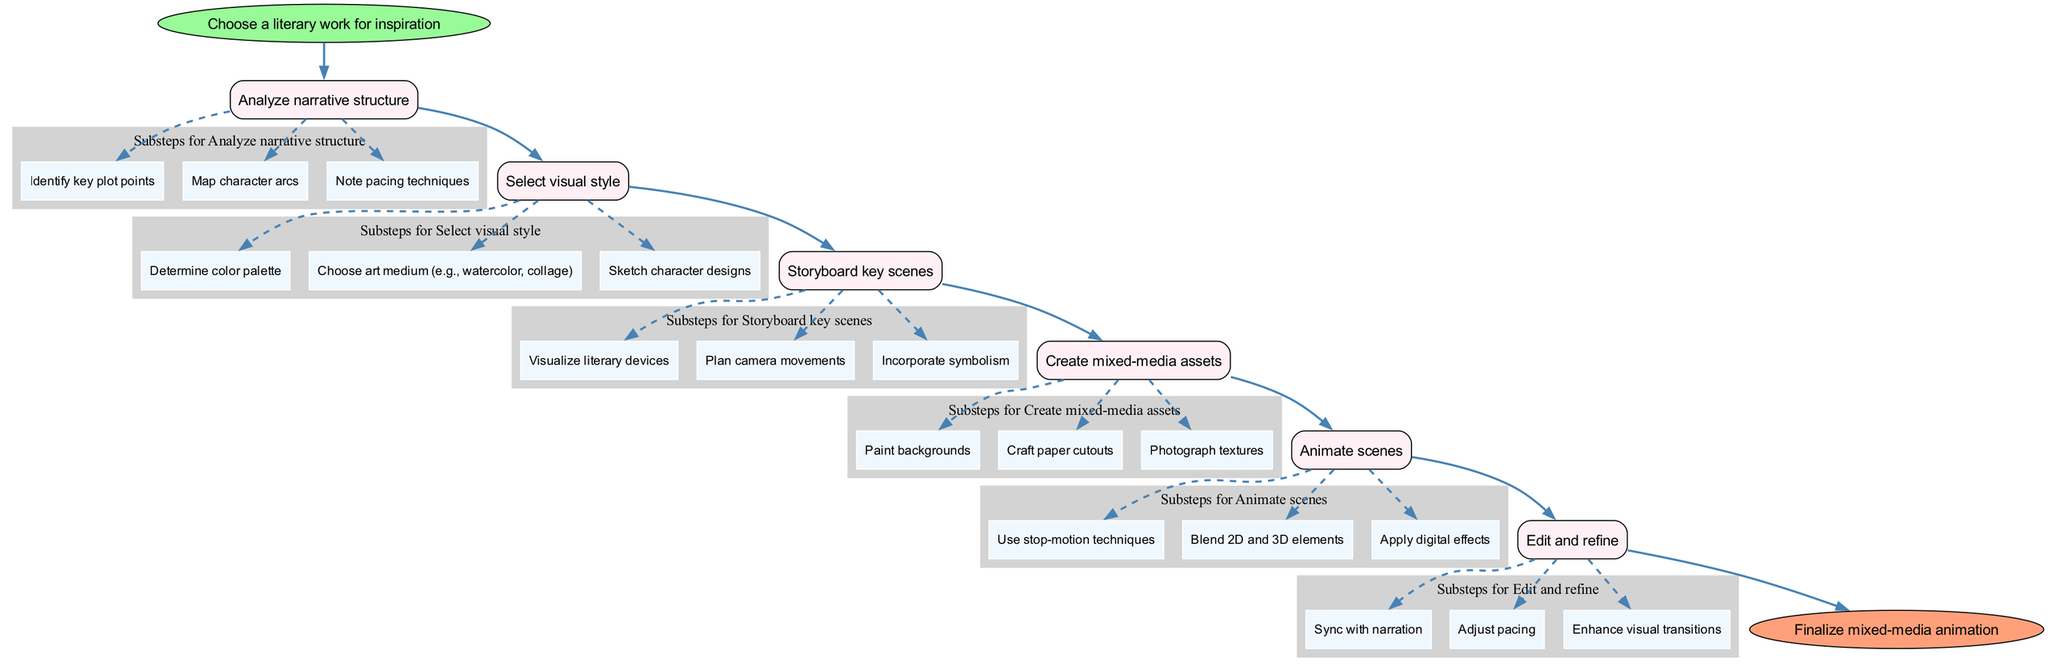What is the first step in the animation process? The diagram indicates that the first step is to "Choose a literary work for inspiration." This is the starting point before any other actions are taken in the animation creation process.
Answer: Choose a literary work for inspiration How many main steps are there in the guide? By counting the steps listed under the "steps" section of the diagram, there are a total of 6 main steps outlined in the process for creating mixed-media animation.
Answer: 6 What does the last step in the process involve? The final step indicated in the diagram states "Finalize mixed-media animation." This is the concluding action to complete the animation process.
Answer: Finalize mixed-media animation Which step includes character designs? In the diagram, the step titled "Select visual style" includes the substep "Sketch character designs," highlighting that character designs are part of the visual style selection.
Answer: Select visual style What two elements are combined in the "Animate scenes" step? The "Animate scenes" step involves blending 2D and 3D elements. This indicates the integration of both types of animation techniques in this step.
Answer: 2D and 3D elements What is the relationship between the "Storyboard key scenes" and "Animate scenes" steps? The relationship is sequential; "Storyboard key scenes" leads directly to the "Animate scenes" step, indicating that storyboarding must occur before the animation process can begin.
Answer: Sequential relationship Which substep focuses on visual symbols? The substep titled "Incorporate symbolism" within the "Storyboard key scenes" step focuses specifically on visual symbols that will be included in the animation.
Answer: Incorporate symbolism How do you determine the color choices? The color choices are determined in the step titled "Select visual style," specifically in the substep "Determine color palette," which outlines that this decision is made during the visual style selection process.
Answer: Select visual style What is emphasized in the "Edit and refine" step? The "Edit and refine" step emphasizes synchronizing with narration, adjusting pacing, and enhancing visual transitions, highlighting that post-animation adjustments are critical for finalizing the animation.
Answer: Adjust pacing 